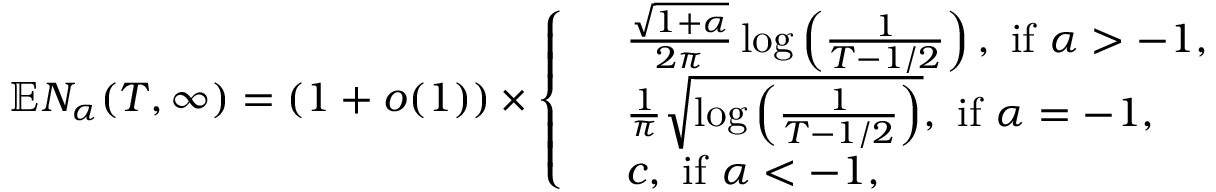Convert formula to latex. <formula><loc_0><loc_0><loc_500><loc_500>\mathbb { E } N _ { \alpha } ( T , \infty ) = ( 1 + o ( 1 ) ) \times \left \{ \begin{array} { l l } & { \frac { \sqrt { 1 + \alpha } } { 2 \pi } \log \left ( \frac { 1 } { T - 1 / 2 } \right ) , i f \alpha > - 1 , } \\ & { \frac { 1 } { \pi } \sqrt { \log \left ( \frac { 1 } { T - 1 / 2 } \right ) } , i f \alpha = - 1 , } \\ & { c , i f \alpha < - 1 , } \end{array}</formula> 